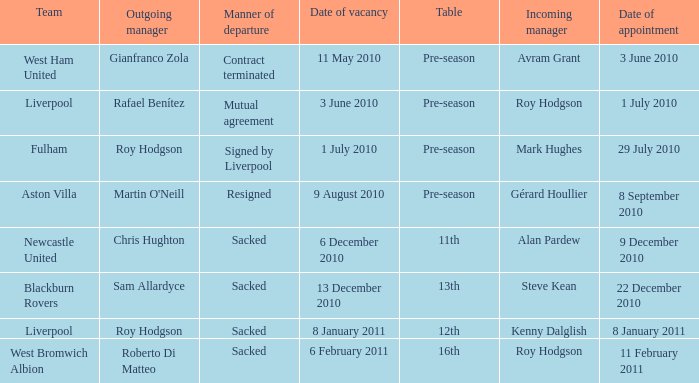What was the scheduled date for incoming manager roy hodgson to join the liverpool team? 1 July 2010. 